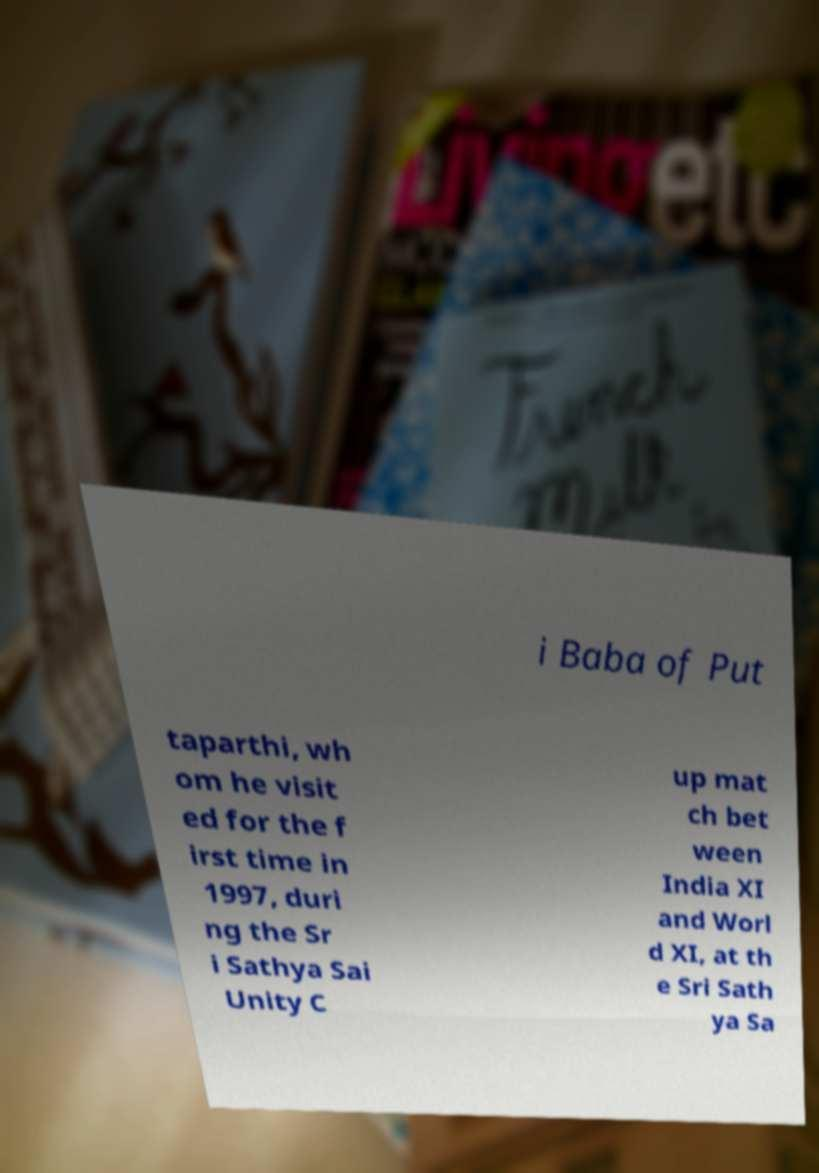Could you extract and type out the text from this image? i Baba of Put taparthi, wh om he visit ed for the f irst time in 1997, duri ng the Sr i Sathya Sai Unity C up mat ch bet ween India XI and Worl d XI, at th e Sri Sath ya Sa 